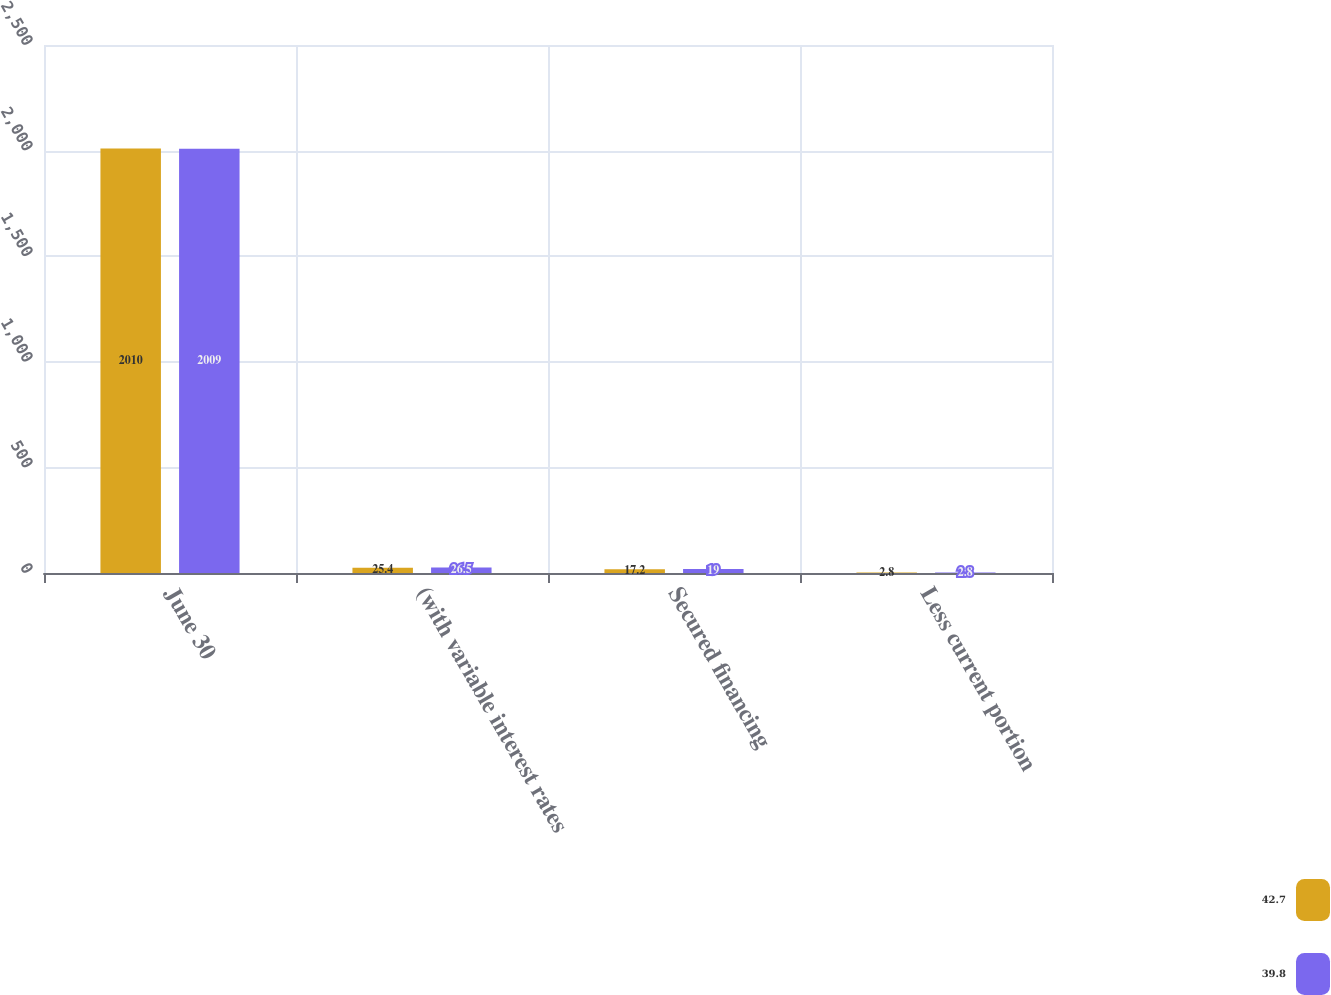Convert chart. <chart><loc_0><loc_0><loc_500><loc_500><stacked_bar_chart><ecel><fcel>June 30<fcel>(with variable interest rates<fcel>Secured financing<fcel>Less current portion<nl><fcel>42.7<fcel>2010<fcel>25.4<fcel>17.2<fcel>2.8<nl><fcel>39.8<fcel>2009<fcel>26.5<fcel>19<fcel>2.8<nl></chart> 